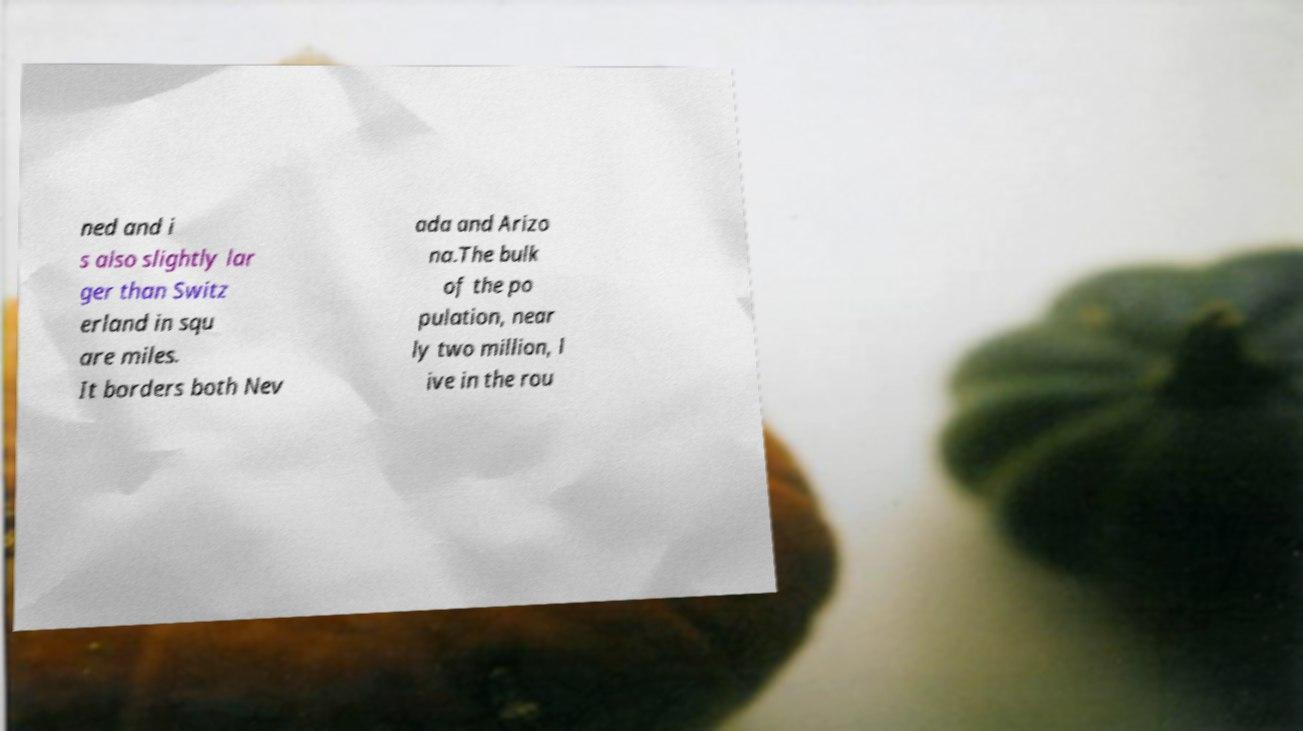Please identify and transcribe the text found in this image. ned and i s also slightly lar ger than Switz erland in squ are miles. It borders both Nev ada and Arizo na.The bulk of the po pulation, near ly two million, l ive in the rou 